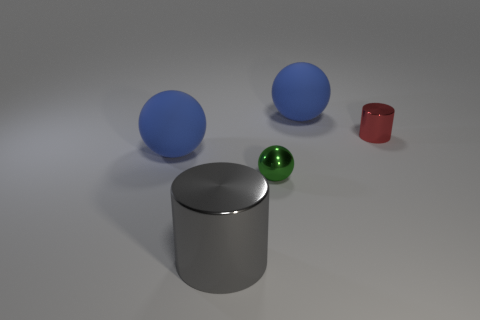Subtract all small green metallic spheres. How many spheres are left? 2 Add 3 gray rubber cylinders. How many objects exist? 8 Subtract 2 balls. How many balls are left? 1 Subtract all cylinders. How many objects are left? 3 Subtract all green cylinders. How many blue spheres are left? 2 Subtract all red cylinders. How many cylinders are left? 1 Subtract 0 red spheres. How many objects are left? 5 Subtract all brown cylinders. Subtract all cyan cubes. How many cylinders are left? 2 Subtract all cylinders. Subtract all cyan matte spheres. How many objects are left? 3 Add 2 matte balls. How many matte balls are left? 4 